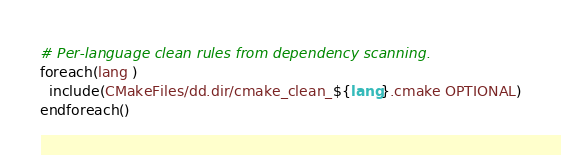<code> <loc_0><loc_0><loc_500><loc_500><_CMake_>
# Per-language clean rules from dependency scanning.
foreach(lang )
  include(CMakeFiles/dd.dir/cmake_clean_${lang}.cmake OPTIONAL)
endforeach()
</code> 